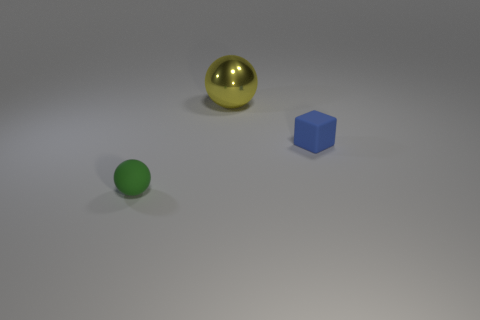Add 3 large green matte cylinders. How many objects exist? 6 Subtract all spheres. How many objects are left? 1 Subtract all small blue rubber spheres. Subtract all big yellow metal spheres. How many objects are left? 2 Add 2 big spheres. How many big spheres are left? 3 Add 1 cyan rubber cylinders. How many cyan rubber cylinders exist? 1 Subtract 1 blue cubes. How many objects are left? 2 